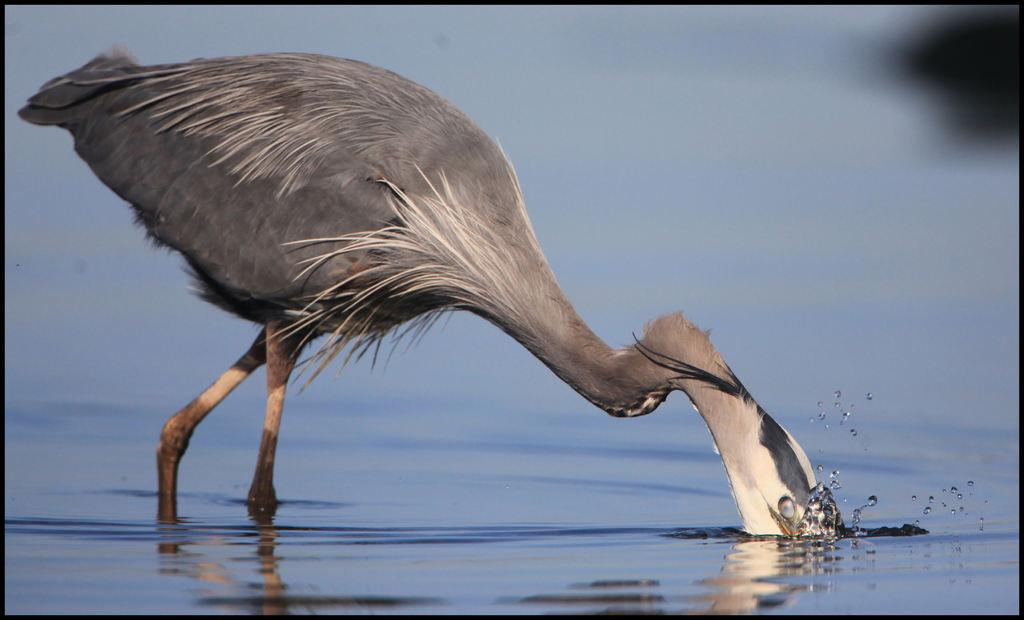What type of animal is present in the image? There is a bird in the image. What is the bird doing in the image? The bird is standing and drinking water. Can you describe the background of the image? The background of the image is blurry. What type of lamp is visible in the image? There is no lamp present in the image. 